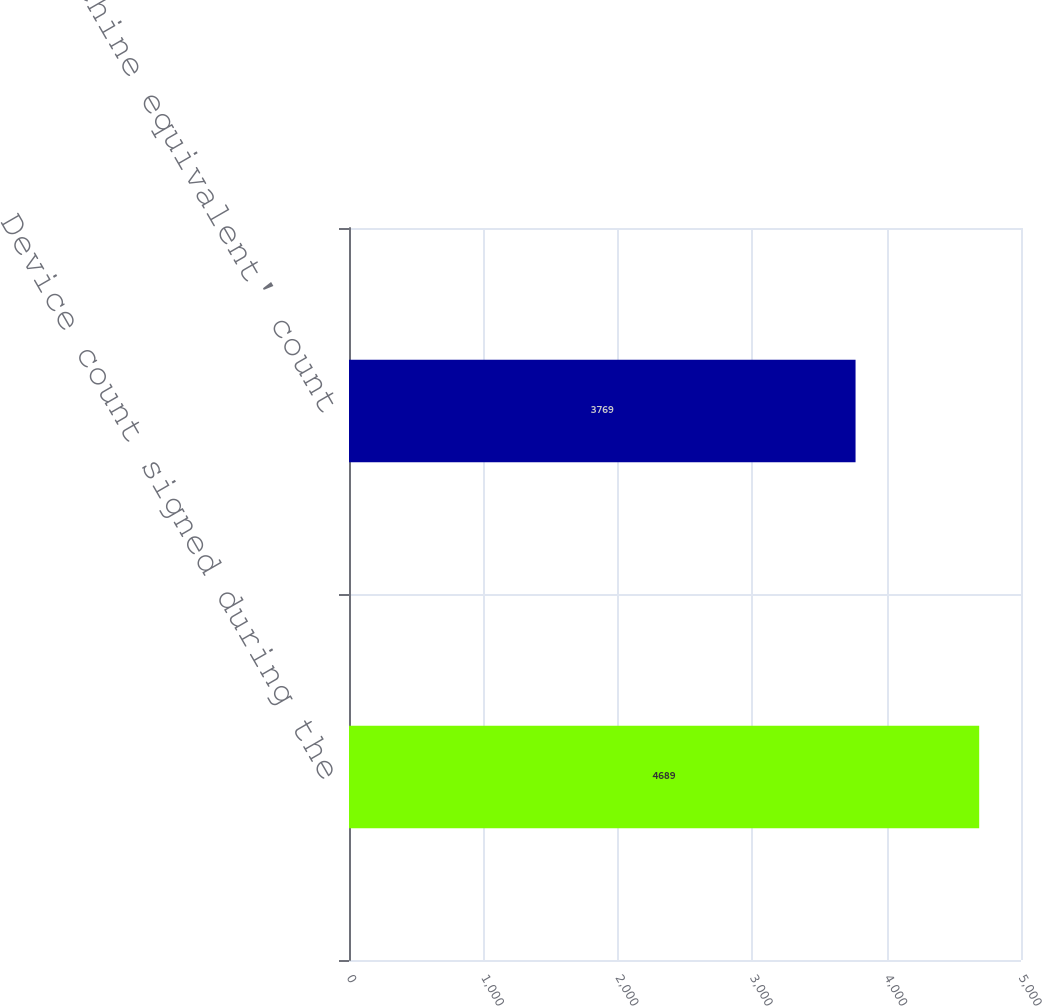Convert chart to OTSL. <chart><loc_0><loc_0><loc_500><loc_500><bar_chart><fcel>Device count signed during the<fcel>'Machine equivalent' count<nl><fcel>4689<fcel>3769<nl></chart> 